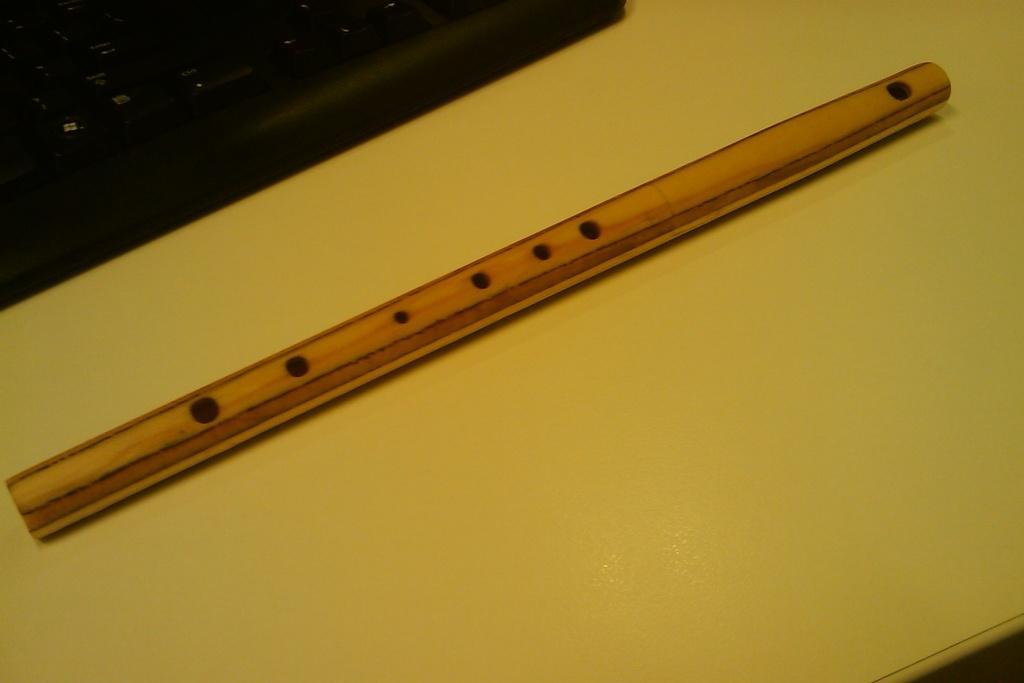How would you summarize this image in a sentence or two? There is a flute on a yellow surface. In the left top corner there is a keyboard. 